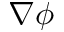Convert formula to latex. <formula><loc_0><loc_0><loc_500><loc_500>\nabla \phi</formula> 